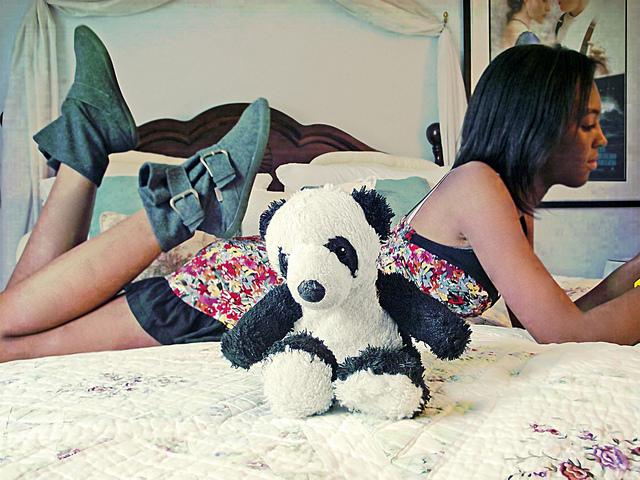How many people are in the photo?
Be succinct. 1. What animal is represented?
Answer briefly. Panda. What color is the girl's hair?
Be succinct. Black. 